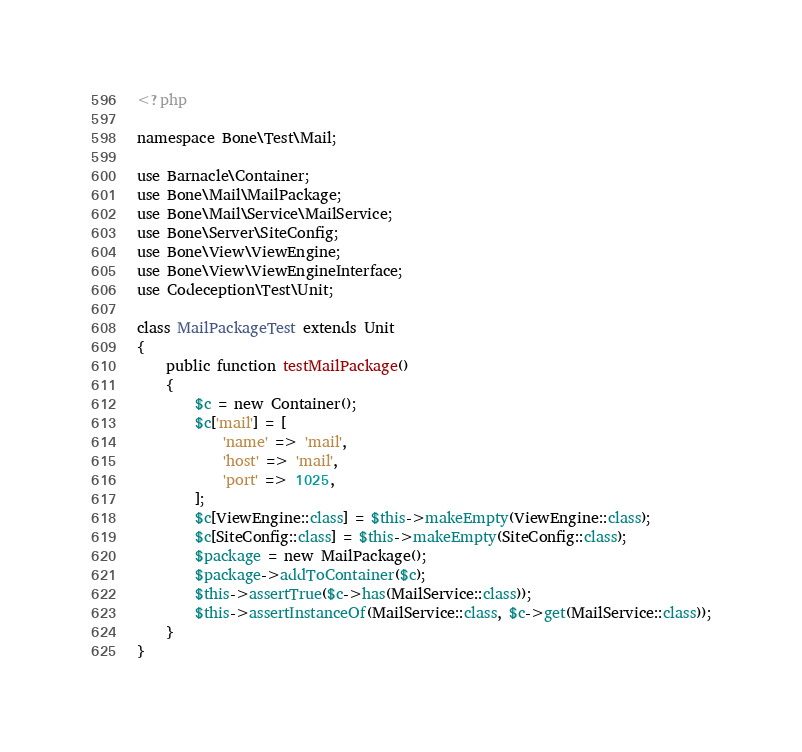<code> <loc_0><loc_0><loc_500><loc_500><_PHP_><?php

namespace Bone\Test\Mail;

use Barnacle\Container;
use Bone\Mail\MailPackage;
use Bone\Mail\Service\MailService;
use Bone\Server\SiteConfig;
use Bone\View\ViewEngine;
use Bone\View\ViewEngineInterface;
use Codeception\Test\Unit;

class MailPackageTest extends Unit
{
    public function testMailPackage()
    {
        $c = new Container();
        $c['mail'] = [
            'name' => 'mail',
            'host' => 'mail',
            'port' => 1025,
        ];
        $c[ViewEngine::class] = $this->makeEmpty(ViewEngine::class);
        $c[SiteConfig::class] = $this->makeEmpty(SiteConfig::class);
        $package = new MailPackage();
        $package->addToContainer($c);
        $this->assertTrue($c->has(MailService::class));
        $this->assertInstanceOf(MailService::class, $c->get(MailService::class));
    }
}
</code> 